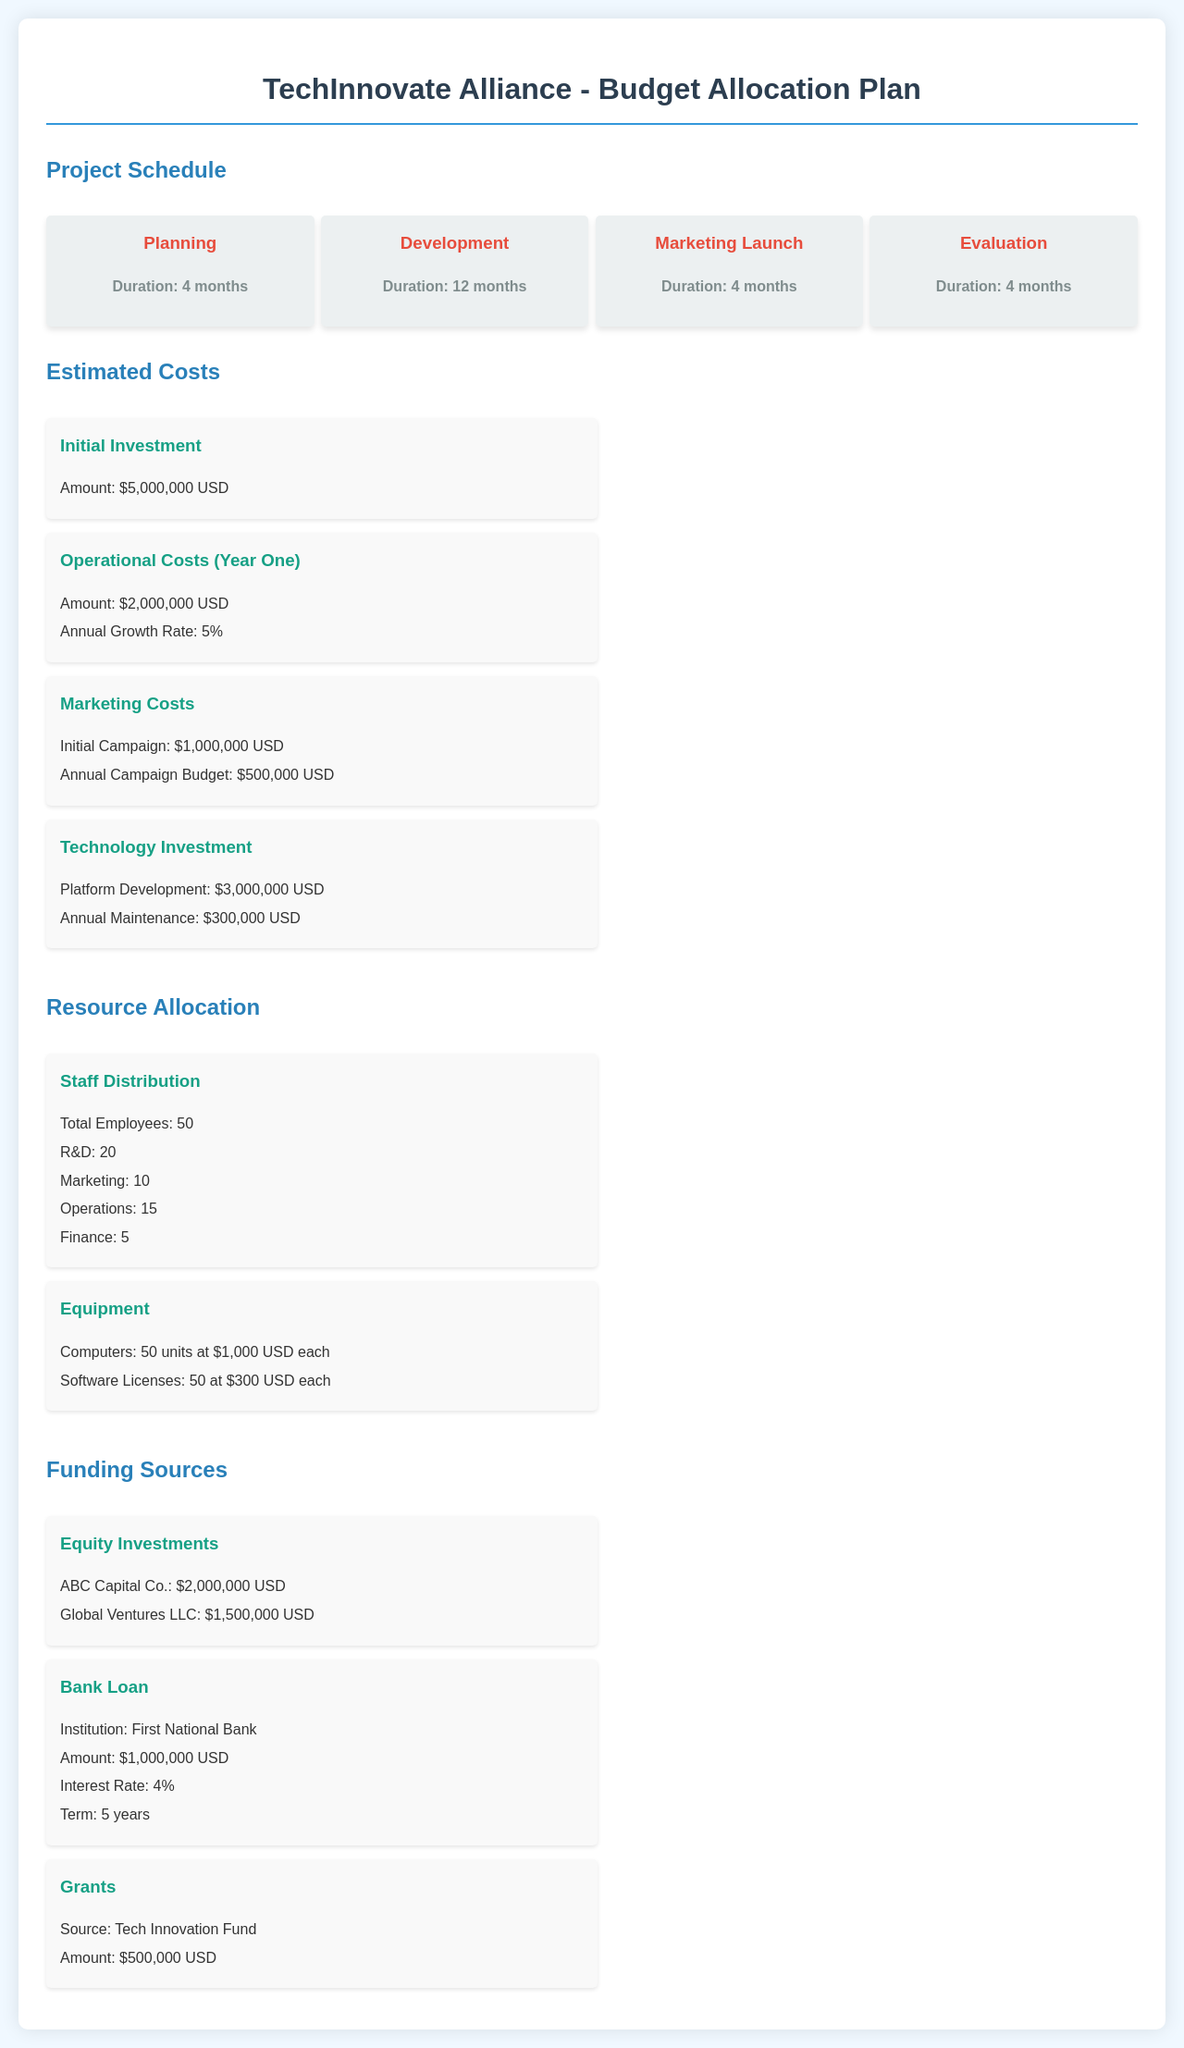What is the total duration of the Planning phase? The duration of the Planning phase is specifically mentioned as 4 months in the Milestone section.
Answer: 4 months What are the estimated operational costs for Year One? The document lists the operational costs for Year One as $2,000,000 USD.
Answer: $2,000,000 USD How much is allocated for the Initial Investment? The Initial Investment amount is specified in the Estimated Costs section as $5,000,000 USD.
Answer: $5,000,000 USD What percentage is the interest rate for the bank loan? The interest rate for the bank loan is detailed as 4% in the Funding Sources section.
Answer: 4% How many employees are designated for R&D? In the Resource Allocation section, it states that there are 20 employees designated for R&D.
Answer: 20 What is the duration of the Evaluation phase? The Evaluation phase duration is specified as 4 months in the Project Schedule section.
Answer: 4 months What is the amount received from ABC Capital Co. as equity investment? The funding from ABC Capital Co. is listed as $2,000,000 USD in the Funding Sources section.
Answer: $2,000,000 USD What is the annual maintenance cost for technology investment? The annual maintenance cost for technology investment is stated as $300,000 USD in the Estimated Costs section.
Answer: $300,000 USD What is the initial campaign budget for marketing? The initial campaign budget for marketing is specified as $1,000,000 USD in the Estimated Costs section.
Answer: $1,000,000 USD 